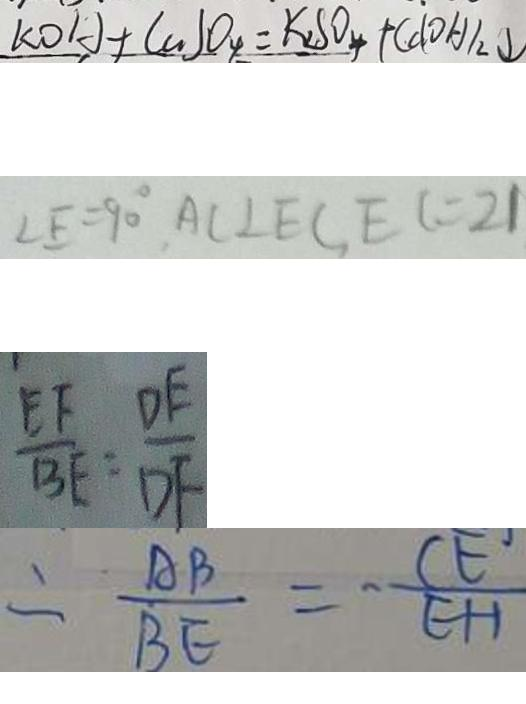Convert formula to latex. <formula><loc_0><loc_0><loc_500><loc_500>K O H + C u S O _ { 4 } = K _ { 2 } S O _ { 4 } + C u ( O H ) _ { 2 } \downarrow 
 \angle E = 9 0 ^ { \circ } , A C \bot E C , E C = 2 1 
 \frac { E F } { B E } = \frac { D E } { D F } 
 \therefore \frac { A B } { B E } = - \frac { C E } { E H }</formula> 